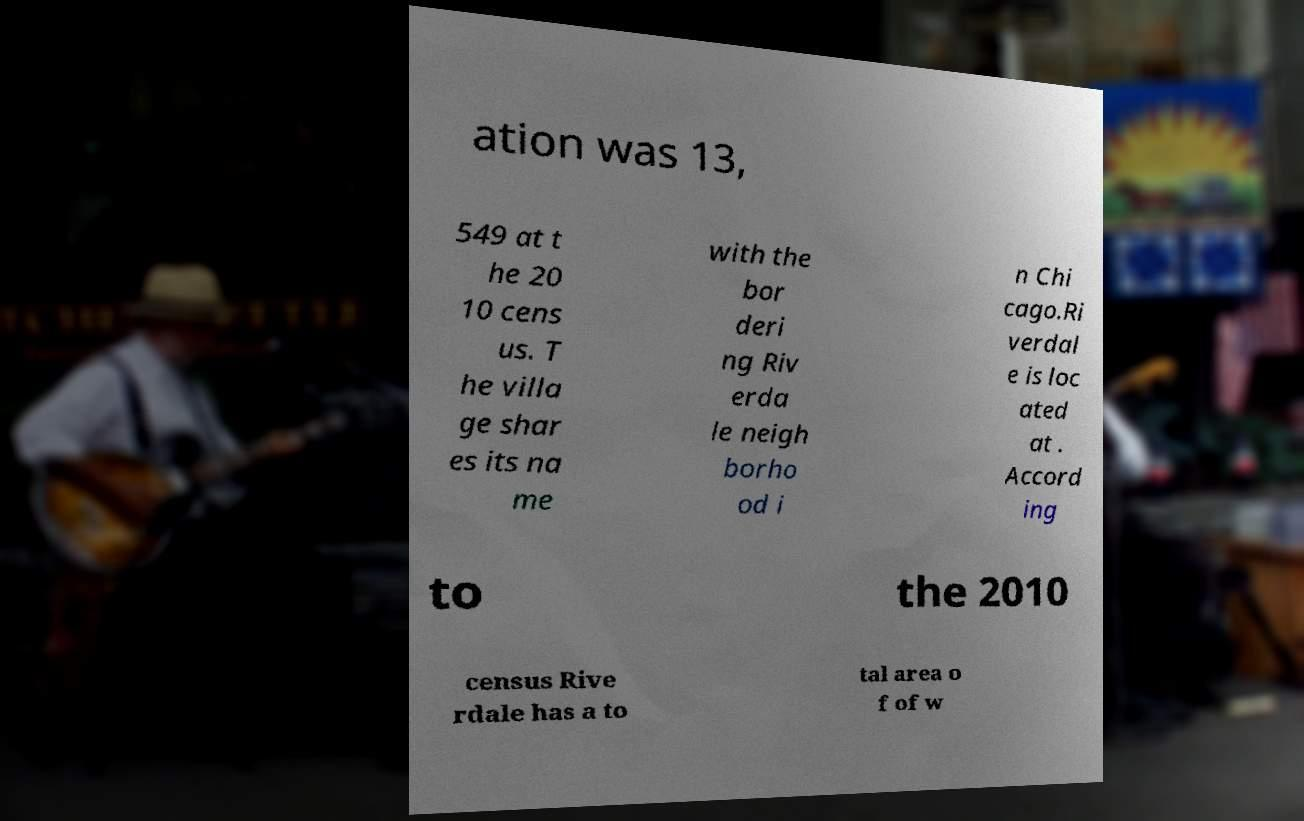Could you extract and type out the text from this image? ation was 13, 549 at t he 20 10 cens us. T he villa ge shar es its na me with the bor deri ng Riv erda le neigh borho od i n Chi cago.Ri verdal e is loc ated at . Accord ing to the 2010 census Rive rdale has a to tal area o f of w 